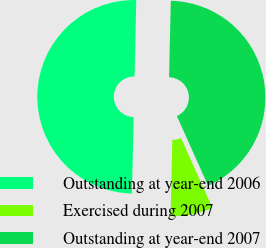Convert chart to OTSL. <chart><loc_0><loc_0><loc_500><loc_500><pie_chart><fcel>Outstanding at year-end 2006<fcel>Exercised during 2007<fcel>Outstanding at year-end 2007<nl><fcel>50.0%<fcel>7.06%<fcel>42.94%<nl></chart> 